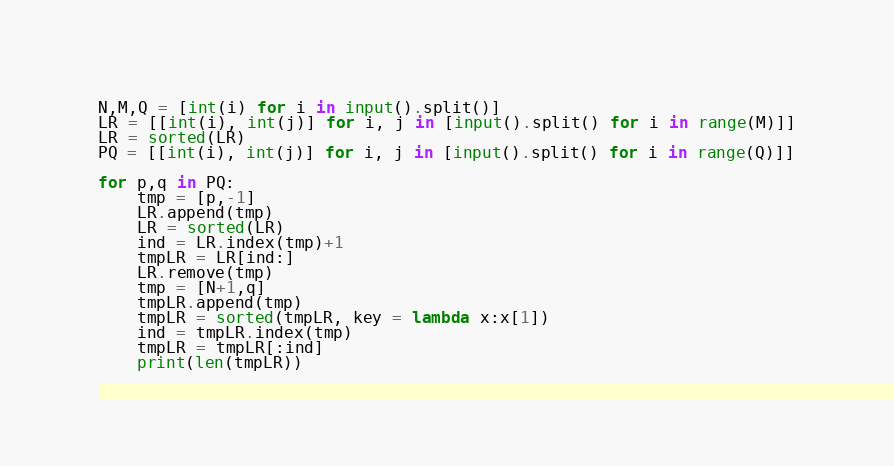Convert code to text. <code><loc_0><loc_0><loc_500><loc_500><_Python_>N,M,Q = [int(i) for i in input().split()]
LR = [[int(i), int(j)] for i, j in [input().split() for i in range(M)]]
LR = sorted(LR)
PQ = [[int(i), int(j)] for i, j in [input().split() for i in range(Q)]]
    
for p,q in PQ:
    tmp = [p,-1]
    LR.append(tmp)
    LR = sorted(LR)
    ind = LR.index(tmp)+1
    tmpLR = LR[ind:]
    LR.remove(tmp)
    tmp = [N+1,q]
    tmpLR.append(tmp)
    tmpLR = sorted(tmpLR, key = lambda x:x[1])
    ind = tmpLR.index(tmp)
    tmpLR = tmpLR[:ind]
    print(len(tmpLR))</code> 